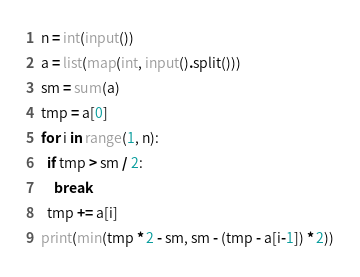<code> <loc_0><loc_0><loc_500><loc_500><_Python_>n = int(input())
a = list(map(int, input().split()))
sm = sum(a)
tmp = a[0]
for i in range(1, n):
  if tmp > sm / 2:
    break
  tmp += a[i]
print(min(tmp * 2 - sm, sm - (tmp - a[i-1]) * 2))</code> 